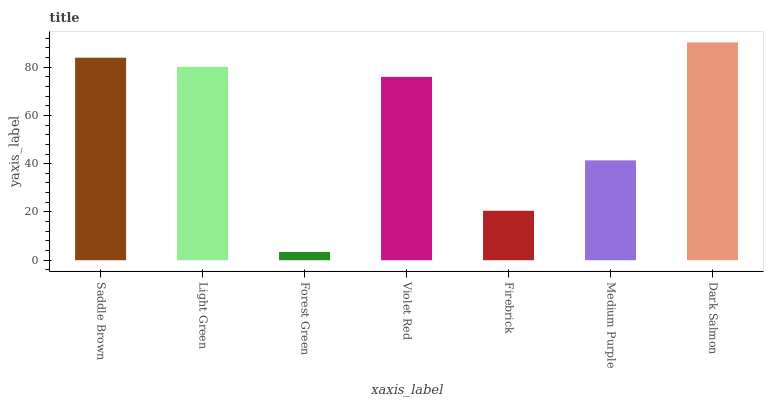Is Forest Green the minimum?
Answer yes or no. Yes. Is Dark Salmon the maximum?
Answer yes or no. Yes. Is Light Green the minimum?
Answer yes or no. No. Is Light Green the maximum?
Answer yes or no. No. Is Saddle Brown greater than Light Green?
Answer yes or no. Yes. Is Light Green less than Saddle Brown?
Answer yes or no. Yes. Is Light Green greater than Saddle Brown?
Answer yes or no. No. Is Saddle Brown less than Light Green?
Answer yes or no. No. Is Violet Red the high median?
Answer yes or no. Yes. Is Violet Red the low median?
Answer yes or no. Yes. Is Saddle Brown the high median?
Answer yes or no. No. Is Firebrick the low median?
Answer yes or no. No. 